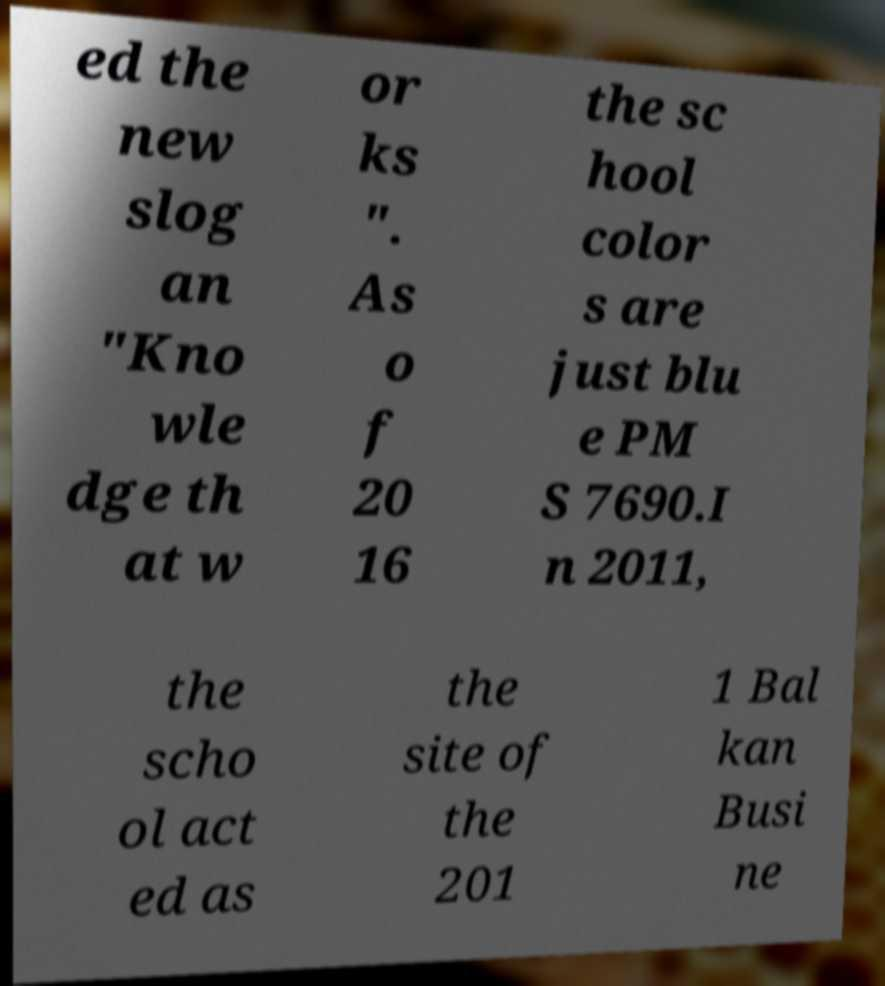Can you accurately transcribe the text from the provided image for me? ed the new slog an "Kno wle dge th at w or ks ". As o f 20 16 the sc hool color s are just blu e PM S 7690.I n 2011, the scho ol act ed as the site of the 201 1 Bal kan Busi ne 